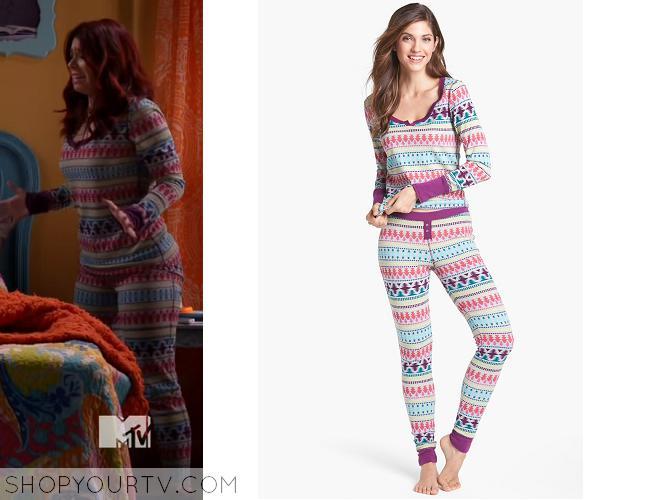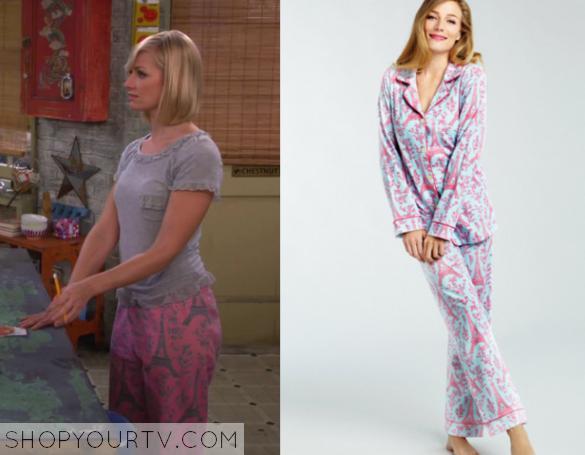The first image is the image on the left, the second image is the image on the right. For the images shown, is this caption "There is at least 1 person facing right in the right image." true? Answer yes or no. No. 